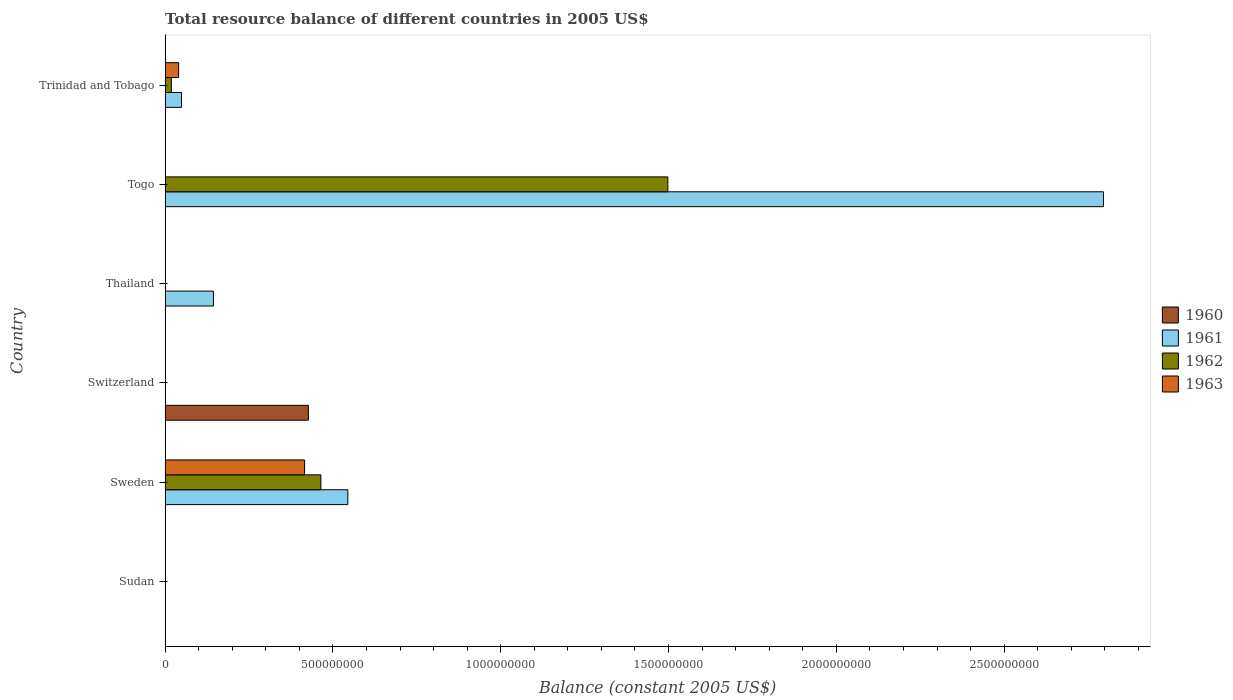What is the label of the 4th group of bars from the top?
Provide a short and direct response. Switzerland. Across all countries, what is the maximum total resource balance in 1962?
Ensure brevity in your answer.  1.50e+09. In which country was the total resource balance in 1962 maximum?
Give a very brief answer. Togo. What is the total total resource balance in 1962 in the graph?
Ensure brevity in your answer.  1.98e+09. What is the difference between the total resource balance in 1962 in Togo and that in Trinidad and Tobago?
Offer a very short reply. 1.48e+09. What is the difference between the total resource balance in 1961 in Switzerland and the total resource balance in 1962 in Thailand?
Provide a short and direct response. 0. What is the average total resource balance in 1963 per country?
Provide a short and direct response. 7.60e+07. What is the difference between the total resource balance in 1961 and total resource balance in 1962 in Togo?
Provide a succinct answer. 1.30e+09. Is the total resource balance in 1962 in Sweden less than that in Togo?
Provide a short and direct response. Yes. What is the difference between the highest and the second highest total resource balance in 1961?
Keep it short and to the point. 2.25e+09. What is the difference between the highest and the lowest total resource balance in 1963?
Your response must be concise. 4.16e+08. Is the sum of the total resource balance in 1961 in Sweden and Togo greater than the maximum total resource balance in 1960 across all countries?
Your response must be concise. Yes. Is it the case that in every country, the sum of the total resource balance in 1963 and total resource balance in 1960 is greater than the sum of total resource balance in 1961 and total resource balance in 1962?
Offer a terse response. No. Is it the case that in every country, the sum of the total resource balance in 1963 and total resource balance in 1961 is greater than the total resource balance in 1960?
Offer a very short reply. No. How many bars are there?
Ensure brevity in your answer.  11. Are all the bars in the graph horizontal?
Provide a succinct answer. Yes. How many countries are there in the graph?
Your answer should be very brief. 6. What is the difference between two consecutive major ticks on the X-axis?
Your answer should be very brief. 5.00e+08. Where does the legend appear in the graph?
Offer a terse response. Center right. How many legend labels are there?
Offer a very short reply. 4. What is the title of the graph?
Your answer should be very brief. Total resource balance of different countries in 2005 US$. What is the label or title of the X-axis?
Your answer should be compact. Balance (constant 2005 US$). What is the Balance (constant 2005 US$) in 1960 in Sudan?
Provide a short and direct response. 6100. What is the Balance (constant 2005 US$) of 1962 in Sudan?
Your answer should be very brief. 0. What is the Balance (constant 2005 US$) of 1960 in Sweden?
Provide a short and direct response. 0. What is the Balance (constant 2005 US$) in 1961 in Sweden?
Provide a short and direct response. 5.44e+08. What is the Balance (constant 2005 US$) in 1962 in Sweden?
Your answer should be compact. 4.64e+08. What is the Balance (constant 2005 US$) of 1963 in Sweden?
Make the answer very short. 4.16e+08. What is the Balance (constant 2005 US$) of 1960 in Switzerland?
Ensure brevity in your answer.  4.27e+08. What is the Balance (constant 2005 US$) of 1961 in Thailand?
Provide a succinct answer. 1.44e+08. What is the Balance (constant 2005 US$) in 1962 in Thailand?
Keep it short and to the point. 0. What is the Balance (constant 2005 US$) in 1963 in Thailand?
Keep it short and to the point. 0. What is the Balance (constant 2005 US$) of 1961 in Togo?
Provide a succinct answer. 2.80e+09. What is the Balance (constant 2005 US$) of 1962 in Togo?
Give a very brief answer. 1.50e+09. What is the Balance (constant 2005 US$) of 1960 in Trinidad and Tobago?
Offer a very short reply. 0. What is the Balance (constant 2005 US$) in 1961 in Trinidad and Tobago?
Provide a short and direct response. 4.88e+07. What is the Balance (constant 2005 US$) of 1962 in Trinidad and Tobago?
Your answer should be compact. 1.86e+07. What is the Balance (constant 2005 US$) of 1963 in Trinidad and Tobago?
Your response must be concise. 4.03e+07. Across all countries, what is the maximum Balance (constant 2005 US$) of 1960?
Offer a very short reply. 4.27e+08. Across all countries, what is the maximum Balance (constant 2005 US$) in 1961?
Your answer should be compact. 2.80e+09. Across all countries, what is the maximum Balance (constant 2005 US$) of 1962?
Keep it short and to the point. 1.50e+09. Across all countries, what is the maximum Balance (constant 2005 US$) of 1963?
Ensure brevity in your answer.  4.16e+08. Across all countries, what is the minimum Balance (constant 2005 US$) in 1960?
Offer a very short reply. 0. Across all countries, what is the minimum Balance (constant 2005 US$) in 1961?
Your answer should be very brief. 0. Across all countries, what is the minimum Balance (constant 2005 US$) of 1963?
Provide a short and direct response. 0. What is the total Balance (constant 2005 US$) of 1960 in the graph?
Provide a succinct answer. 4.27e+08. What is the total Balance (constant 2005 US$) of 1961 in the graph?
Your response must be concise. 3.53e+09. What is the total Balance (constant 2005 US$) in 1962 in the graph?
Your answer should be compact. 1.98e+09. What is the total Balance (constant 2005 US$) in 1963 in the graph?
Provide a succinct answer. 4.56e+08. What is the difference between the Balance (constant 2005 US$) in 1960 in Sudan and that in Switzerland?
Offer a very short reply. -4.27e+08. What is the difference between the Balance (constant 2005 US$) in 1961 in Sweden and that in Thailand?
Your response must be concise. 4.00e+08. What is the difference between the Balance (constant 2005 US$) of 1961 in Sweden and that in Togo?
Your answer should be very brief. -2.25e+09. What is the difference between the Balance (constant 2005 US$) of 1962 in Sweden and that in Togo?
Provide a succinct answer. -1.03e+09. What is the difference between the Balance (constant 2005 US$) in 1961 in Sweden and that in Trinidad and Tobago?
Your answer should be compact. 4.96e+08. What is the difference between the Balance (constant 2005 US$) in 1962 in Sweden and that in Trinidad and Tobago?
Your answer should be compact. 4.46e+08. What is the difference between the Balance (constant 2005 US$) of 1963 in Sweden and that in Trinidad and Tobago?
Give a very brief answer. 3.75e+08. What is the difference between the Balance (constant 2005 US$) in 1961 in Thailand and that in Togo?
Offer a terse response. -2.65e+09. What is the difference between the Balance (constant 2005 US$) of 1961 in Thailand and that in Trinidad and Tobago?
Your answer should be compact. 9.52e+07. What is the difference between the Balance (constant 2005 US$) of 1961 in Togo and that in Trinidad and Tobago?
Offer a terse response. 2.75e+09. What is the difference between the Balance (constant 2005 US$) in 1962 in Togo and that in Trinidad and Tobago?
Offer a terse response. 1.48e+09. What is the difference between the Balance (constant 2005 US$) of 1960 in Sudan and the Balance (constant 2005 US$) of 1961 in Sweden?
Provide a short and direct response. -5.44e+08. What is the difference between the Balance (constant 2005 US$) in 1960 in Sudan and the Balance (constant 2005 US$) in 1962 in Sweden?
Your answer should be compact. -4.64e+08. What is the difference between the Balance (constant 2005 US$) in 1960 in Sudan and the Balance (constant 2005 US$) in 1963 in Sweden?
Offer a terse response. -4.16e+08. What is the difference between the Balance (constant 2005 US$) of 1960 in Sudan and the Balance (constant 2005 US$) of 1961 in Thailand?
Make the answer very short. -1.44e+08. What is the difference between the Balance (constant 2005 US$) of 1960 in Sudan and the Balance (constant 2005 US$) of 1961 in Togo?
Your answer should be compact. -2.80e+09. What is the difference between the Balance (constant 2005 US$) of 1960 in Sudan and the Balance (constant 2005 US$) of 1962 in Togo?
Your answer should be very brief. -1.50e+09. What is the difference between the Balance (constant 2005 US$) of 1960 in Sudan and the Balance (constant 2005 US$) of 1961 in Trinidad and Tobago?
Offer a terse response. -4.88e+07. What is the difference between the Balance (constant 2005 US$) of 1960 in Sudan and the Balance (constant 2005 US$) of 1962 in Trinidad and Tobago?
Offer a terse response. -1.86e+07. What is the difference between the Balance (constant 2005 US$) in 1960 in Sudan and the Balance (constant 2005 US$) in 1963 in Trinidad and Tobago?
Provide a succinct answer. -4.03e+07. What is the difference between the Balance (constant 2005 US$) in 1961 in Sweden and the Balance (constant 2005 US$) in 1962 in Togo?
Your answer should be compact. -9.53e+08. What is the difference between the Balance (constant 2005 US$) in 1961 in Sweden and the Balance (constant 2005 US$) in 1962 in Trinidad and Tobago?
Offer a very short reply. 5.26e+08. What is the difference between the Balance (constant 2005 US$) in 1961 in Sweden and the Balance (constant 2005 US$) in 1963 in Trinidad and Tobago?
Ensure brevity in your answer.  5.04e+08. What is the difference between the Balance (constant 2005 US$) in 1962 in Sweden and the Balance (constant 2005 US$) in 1963 in Trinidad and Tobago?
Make the answer very short. 4.24e+08. What is the difference between the Balance (constant 2005 US$) of 1960 in Switzerland and the Balance (constant 2005 US$) of 1961 in Thailand?
Your answer should be very brief. 2.83e+08. What is the difference between the Balance (constant 2005 US$) in 1960 in Switzerland and the Balance (constant 2005 US$) in 1961 in Togo?
Provide a succinct answer. -2.37e+09. What is the difference between the Balance (constant 2005 US$) in 1960 in Switzerland and the Balance (constant 2005 US$) in 1962 in Togo?
Provide a succinct answer. -1.07e+09. What is the difference between the Balance (constant 2005 US$) in 1960 in Switzerland and the Balance (constant 2005 US$) in 1961 in Trinidad and Tobago?
Make the answer very short. 3.78e+08. What is the difference between the Balance (constant 2005 US$) of 1960 in Switzerland and the Balance (constant 2005 US$) of 1962 in Trinidad and Tobago?
Keep it short and to the point. 4.08e+08. What is the difference between the Balance (constant 2005 US$) of 1960 in Switzerland and the Balance (constant 2005 US$) of 1963 in Trinidad and Tobago?
Your answer should be very brief. 3.87e+08. What is the difference between the Balance (constant 2005 US$) in 1961 in Thailand and the Balance (constant 2005 US$) in 1962 in Togo?
Keep it short and to the point. -1.35e+09. What is the difference between the Balance (constant 2005 US$) of 1961 in Thailand and the Balance (constant 2005 US$) of 1962 in Trinidad and Tobago?
Make the answer very short. 1.25e+08. What is the difference between the Balance (constant 2005 US$) of 1961 in Thailand and the Balance (constant 2005 US$) of 1963 in Trinidad and Tobago?
Provide a succinct answer. 1.04e+08. What is the difference between the Balance (constant 2005 US$) in 1961 in Togo and the Balance (constant 2005 US$) in 1962 in Trinidad and Tobago?
Give a very brief answer. 2.78e+09. What is the difference between the Balance (constant 2005 US$) in 1961 in Togo and the Balance (constant 2005 US$) in 1963 in Trinidad and Tobago?
Provide a short and direct response. 2.76e+09. What is the difference between the Balance (constant 2005 US$) in 1962 in Togo and the Balance (constant 2005 US$) in 1963 in Trinidad and Tobago?
Your answer should be compact. 1.46e+09. What is the average Balance (constant 2005 US$) of 1960 per country?
Offer a very short reply. 7.12e+07. What is the average Balance (constant 2005 US$) in 1961 per country?
Make the answer very short. 5.89e+08. What is the average Balance (constant 2005 US$) of 1962 per country?
Offer a very short reply. 3.30e+08. What is the average Balance (constant 2005 US$) in 1963 per country?
Ensure brevity in your answer.  7.60e+07. What is the difference between the Balance (constant 2005 US$) of 1961 and Balance (constant 2005 US$) of 1962 in Sweden?
Your answer should be compact. 8.03e+07. What is the difference between the Balance (constant 2005 US$) in 1961 and Balance (constant 2005 US$) in 1963 in Sweden?
Provide a short and direct response. 1.29e+08. What is the difference between the Balance (constant 2005 US$) in 1962 and Balance (constant 2005 US$) in 1963 in Sweden?
Provide a short and direct response. 4.86e+07. What is the difference between the Balance (constant 2005 US$) in 1961 and Balance (constant 2005 US$) in 1962 in Togo?
Offer a very short reply. 1.30e+09. What is the difference between the Balance (constant 2005 US$) in 1961 and Balance (constant 2005 US$) in 1962 in Trinidad and Tobago?
Your response must be concise. 3.02e+07. What is the difference between the Balance (constant 2005 US$) in 1961 and Balance (constant 2005 US$) in 1963 in Trinidad and Tobago?
Provide a short and direct response. 8.50e+06. What is the difference between the Balance (constant 2005 US$) in 1962 and Balance (constant 2005 US$) in 1963 in Trinidad and Tobago?
Your answer should be compact. -2.17e+07. What is the ratio of the Balance (constant 2005 US$) of 1961 in Sweden to that in Thailand?
Provide a short and direct response. 3.78. What is the ratio of the Balance (constant 2005 US$) in 1961 in Sweden to that in Togo?
Offer a very short reply. 0.19. What is the ratio of the Balance (constant 2005 US$) of 1962 in Sweden to that in Togo?
Keep it short and to the point. 0.31. What is the ratio of the Balance (constant 2005 US$) in 1961 in Sweden to that in Trinidad and Tobago?
Your answer should be compact. 11.16. What is the ratio of the Balance (constant 2005 US$) of 1962 in Sweden to that in Trinidad and Tobago?
Ensure brevity in your answer.  24.96. What is the ratio of the Balance (constant 2005 US$) of 1963 in Sweden to that in Trinidad and Tobago?
Your answer should be very brief. 10.31. What is the ratio of the Balance (constant 2005 US$) of 1961 in Thailand to that in Togo?
Provide a short and direct response. 0.05. What is the ratio of the Balance (constant 2005 US$) in 1961 in Thailand to that in Trinidad and Tobago?
Your response must be concise. 2.95. What is the ratio of the Balance (constant 2005 US$) of 1961 in Togo to that in Trinidad and Tobago?
Provide a succinct answer. 57.29. What is the ratio of the Balance (constant 2005 US$) in 1962 in Togo to that in Trinidad and Tobago?
Offer a terse response. 80.54. What is the difference between the highest and the second highest Balance (constant 2005 US$) in 1961?
Ensure brevity in your answer.  2.25e+09. What is the difference between the highest and the second highest Balance (constant 2005 US$) in 1962?
Give a very brief answer. 1.03e+09. What is the difference between the highest and the lowest Balance (constant 2005 US$) in 1960?
Your response must be concise. 4.27e+08. What is the difference between the highest and the lowest Balance (constant 2005 US$) in 1961?
Ensure brevity in your answer.  2.80e+09. What is the difference between the highest and the lowest Balance (constant 2005 US$) in 1962?
Offer a very short reply. 1.50e+09. What is the difference between the highest and the lowest Balance (constant 2005 US$) of 1963?
Your response must be concise. 4.16e+08. 